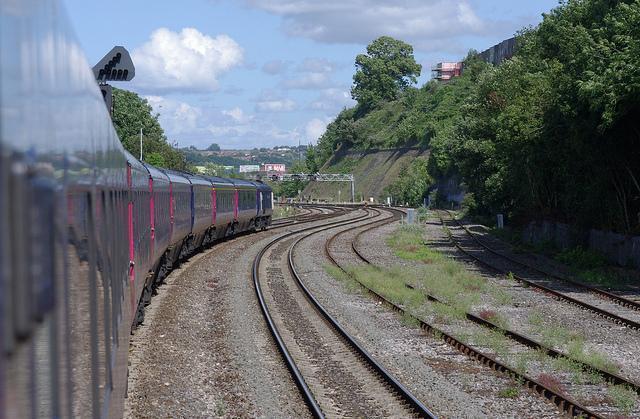How many trains are there?
Give a very brief answer. 1. 